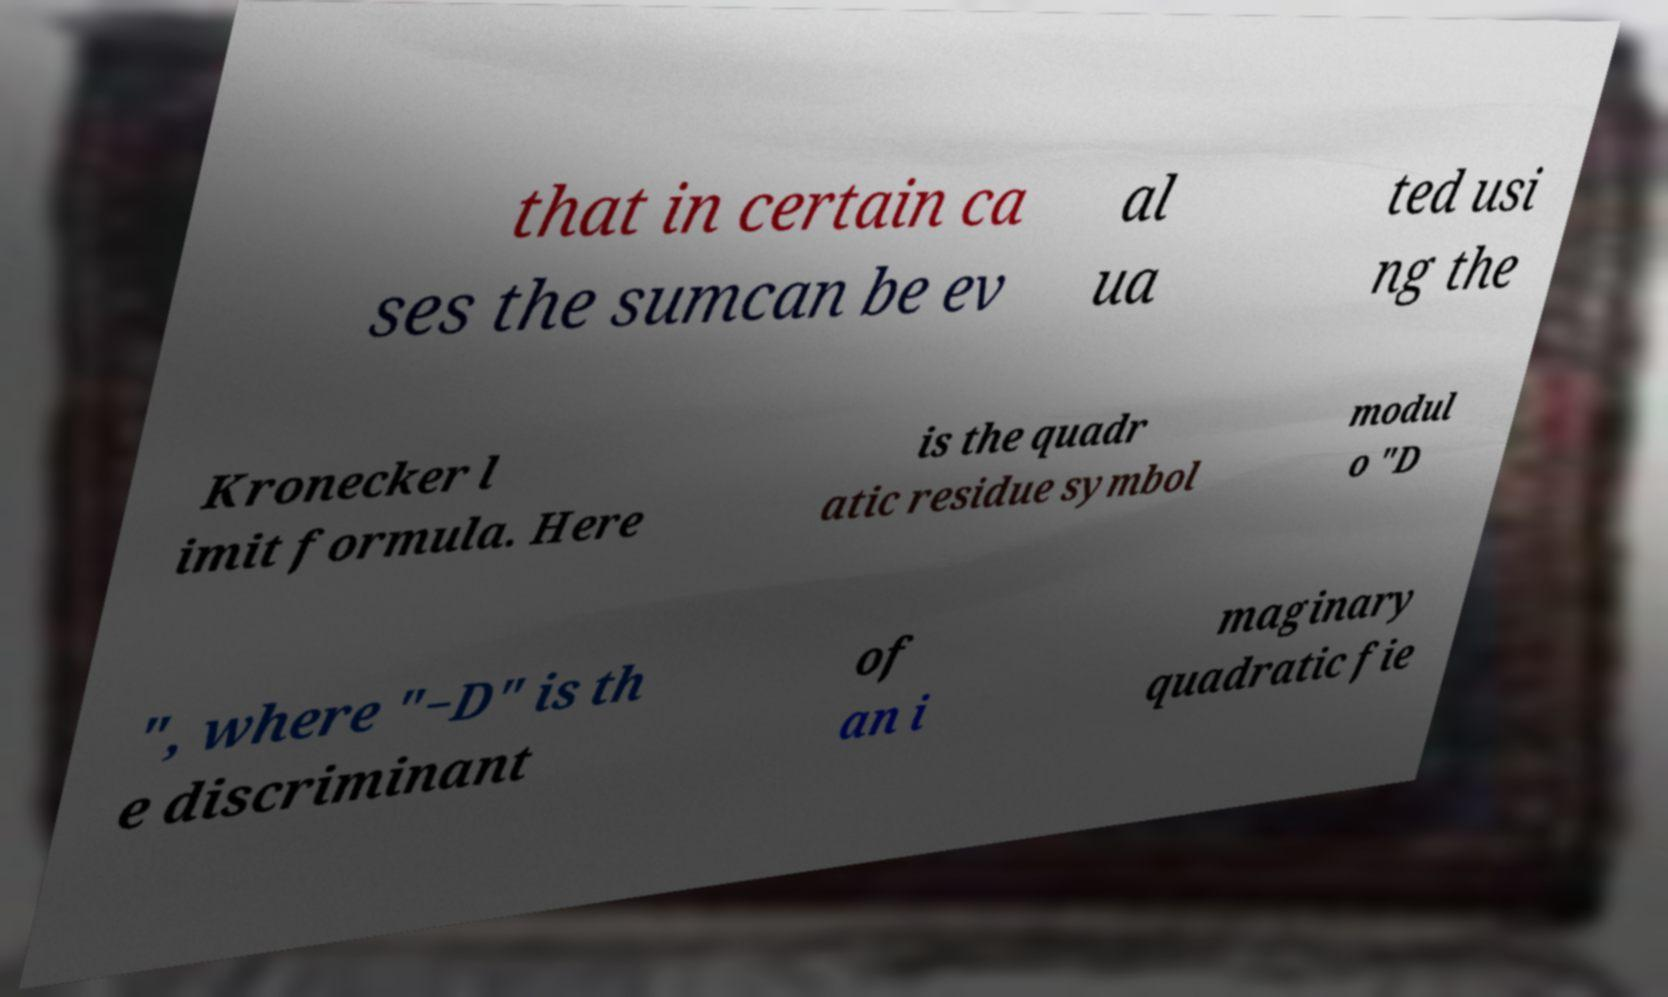Please read and relay the text visible in this image. What does it say? that in certain ca ses the sumcan be ev al ua ted usi ng the Kronecker l imit formula. Here is the quadr atic residue symbol modul o "D ", where "−D" is th e discriminant of an i maginary quadratic fie 